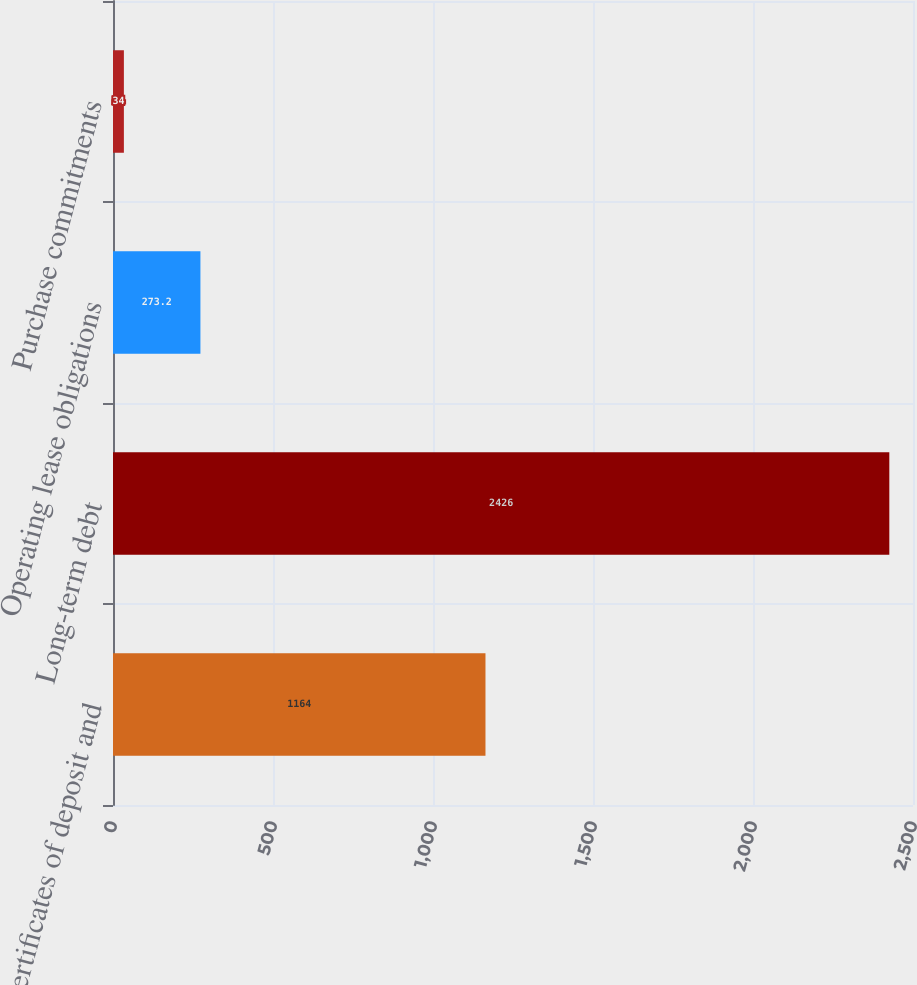Convert chart. <chart><loc_0><loc_0><loc_500><loc_500><bar_chart><fcel>Certificates of deposit and<fcel>Long-term debt<fcel>Operating lease obligations<fcel>Purchase commitments<nl><fcel>1164<fcel>2426<fcel>273.2<fcel>34<nl></chart> 